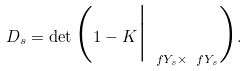<formula> <loc_0><loc_0><loc_500><loc_500>D _ { s } = \det \Big ( 1 - K \Big | _ { \ f Y _ { s } \times \ f Y _ { s } } \Big ) .</formula> 